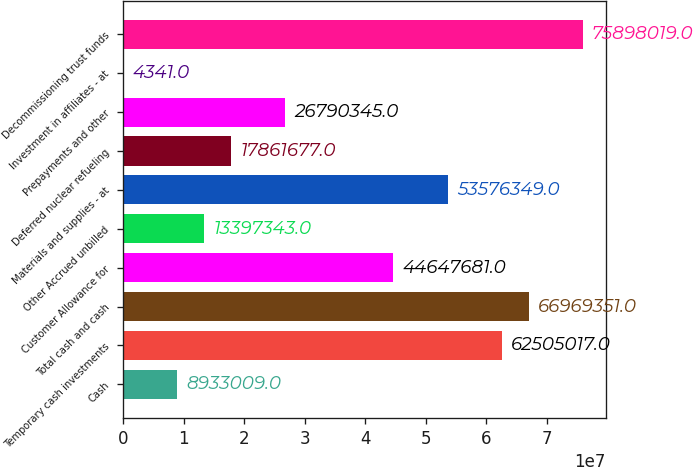Convert chart. <chart><loc_0><loc_0><loc_500><loc_500><bar_chart><fcel>Cash<fcel>Temporary cash investments<fcel>Total cash and cash<fcel>Customer Allowance for<fcel>Other Accrued unbilled<fcel>Materials and supplies - at<fcel>Deferred nuclear refueling<fcel>Prepayments and other<fcel>Investment in affiliates - at<fcel>Decommissioning trust funds<nl><fcel>8.93301e+06<fcel>6.2505e+07<fcel>6.69694e+07<fcel>4.46477e+07<fcel>1.33973e+07<fcel>5.35763e+07<fcel>1.78617e+07<fcel>2.67903e+07<fcel>4341<fcel>7.5898e+07<nl></chart> 